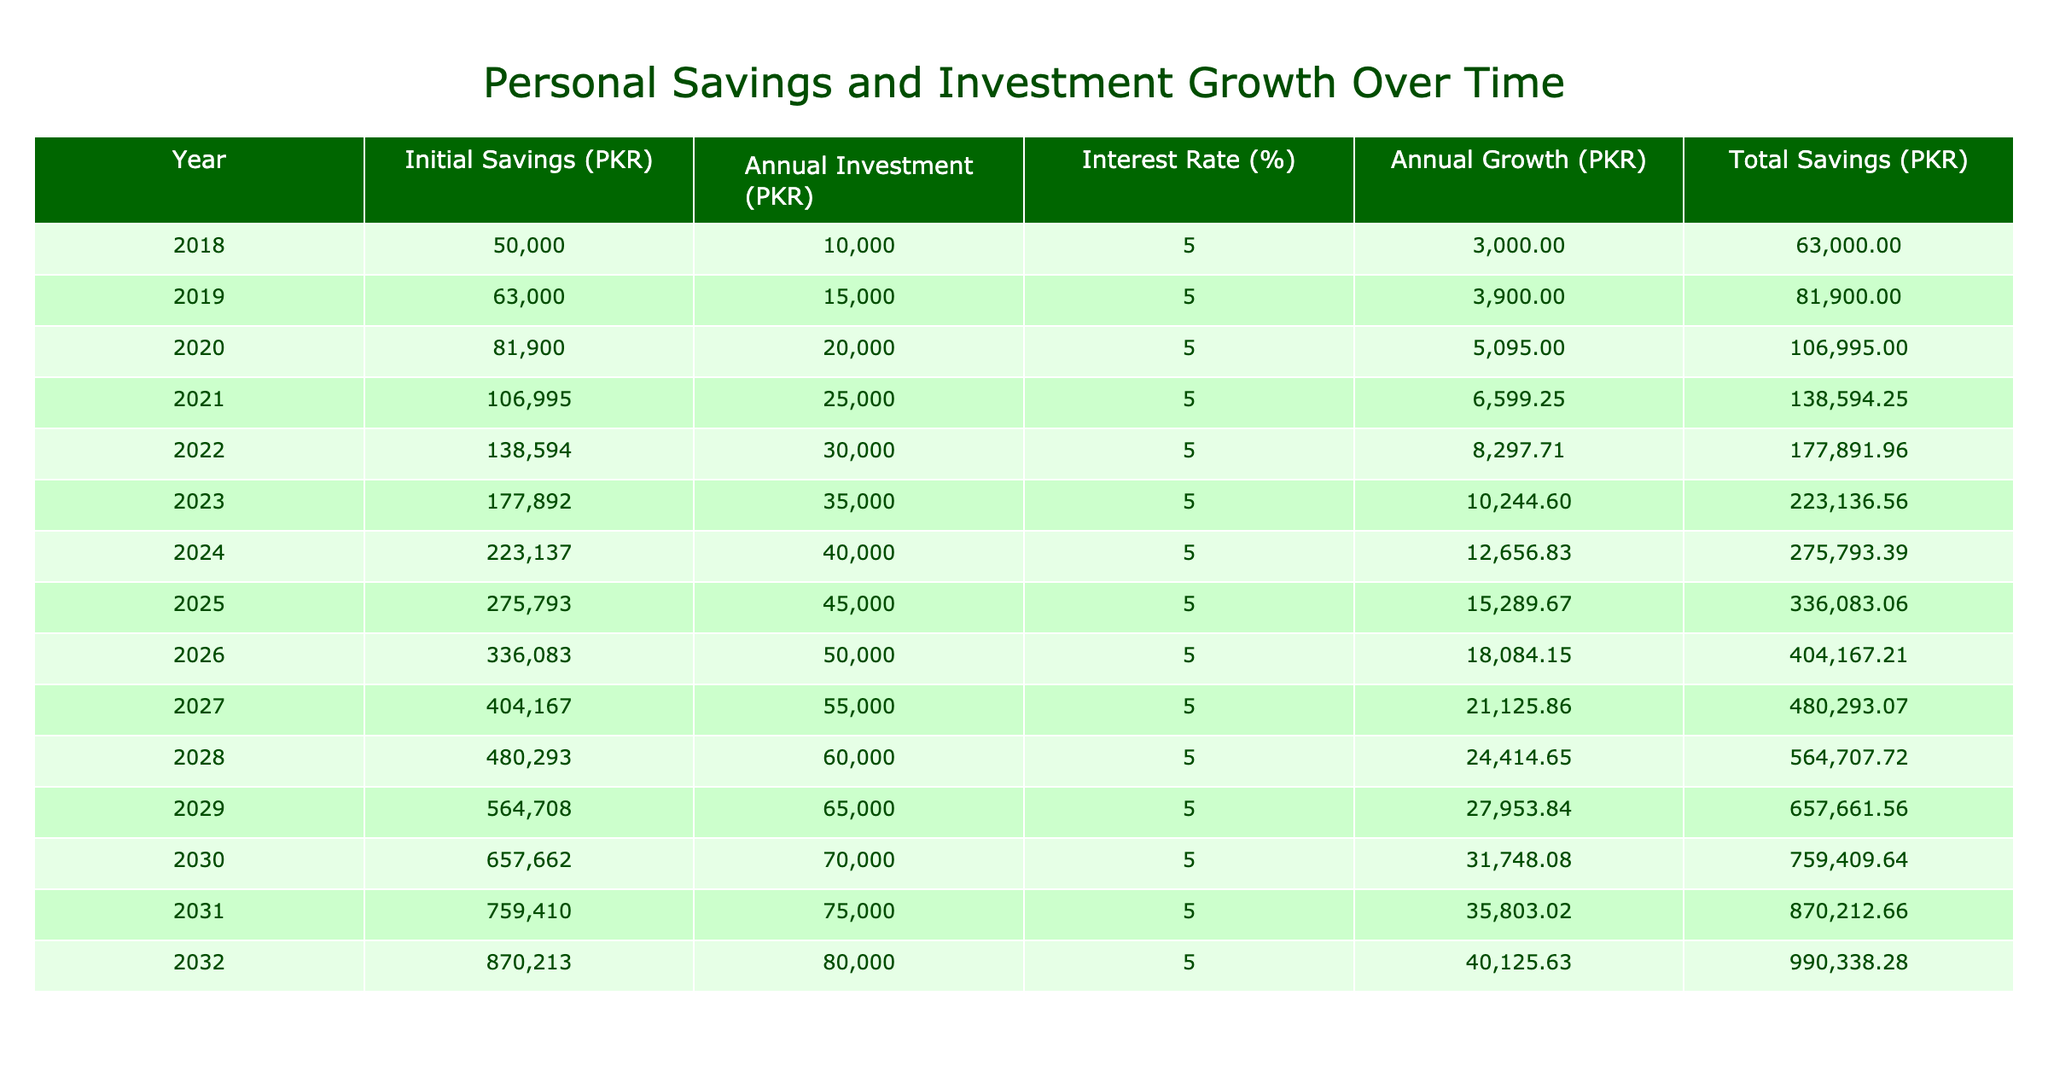What was the total savings in 2023? In the table, under the "Total Savings (PKR)" column, for the year 2023, the value is listed as 223136.56 PKR.
Answer: 223136.56 PKR What was the annual growth in savings in 2025? Referring to the "Annual Growth (PKR)" column for the year 2025, the table states that the annual growth is 15289.67 PKR.
Answer: 15289.67 PKR Is the initial savings in 2022 greater than 150000 PKR? Looking at the "Initial Savings (PKR)" for 2022, it is 138594.25 PKR, which is less than 150000 PKR. Thus, the statement is false.
Answer: No What was the average annual investment from 2018 to 2023? The annual investments from 2018 to 2023 are 10000, 15000, 20000, 25000, 30000, and 35000 PKR. Adding these gives 145000 PKR, and dividing by 6 (the number of years) results in an average of 24166.67 PKR.
Answer: 24166.67 PKR What is the difference in total savings between 2020 and 2022? The total savings in 2020 is 106995 PKR, and in 2022 it is 177891.96 PKR. The difference is calculated as 177891.96 - 106995 = 70896.96 PKR.
Answer: 70896.96 PKR In which year did the annual growth exceed 20000 PKR for the first time? By examining the "Annual Growth (PKR)" column, the first year where the growth exceeds 20000 PKR is 2027, where the growth is 21125.86 PKR.
Answer: 2027 What is the total savings in 2030? The total savings for the year 2030 is found in the "Total Savings (PKR)" column as 759409.64 PKR.
Answer: 759409.64 PKR Was the annual investment higher in 2021 compared to 2019? Looking at the "Annual Investment (PKR)" values, in 2021 it is 25000 PKR, and in 2019 it is 15000 PKR. Since 25000 is greater than 15000, the statement is true.
Answer: Yes 